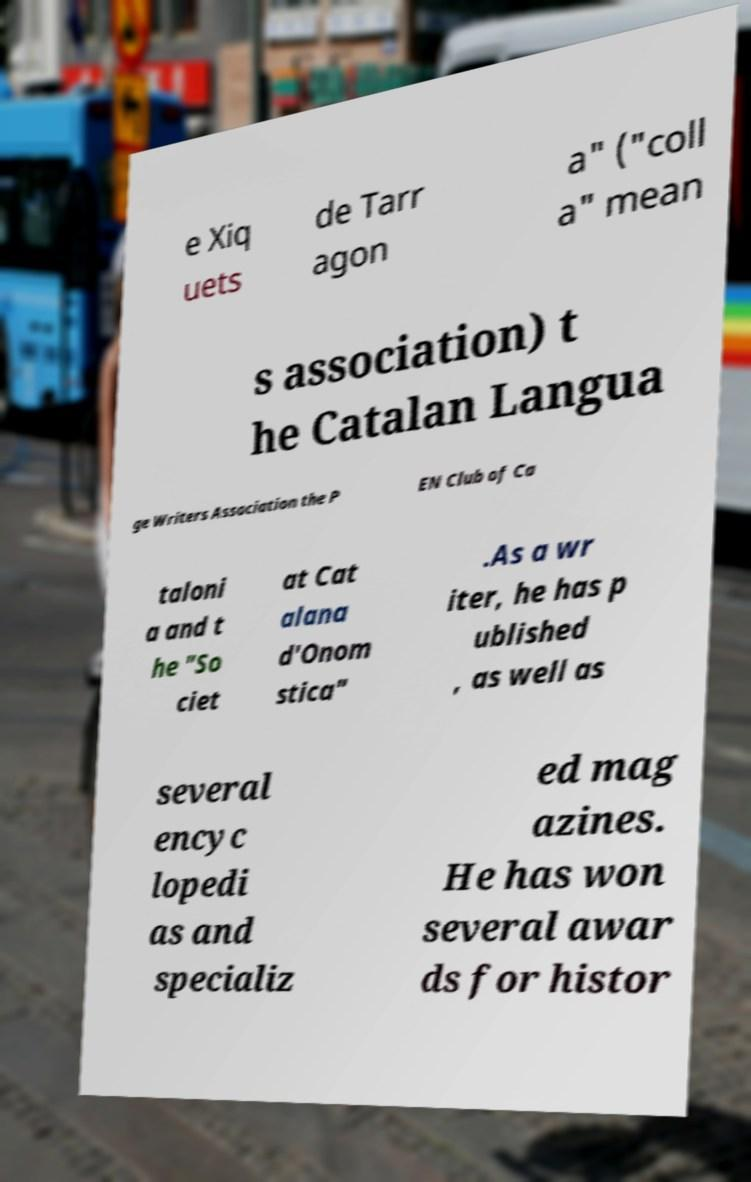Please read and relay the text visible in this image. What does it say? e Xiq uets de Tarr agon a" ("coll a" mean s association) t he Catalan Langua ge Writers Association the P EN Club of Ca taloni a and t he "So ciet at Cat alana d'Onom stica" .As a wr iter, he has p ublished , as well as several encyc lopedi as and specializ ed mag azines. He has won several awar ds for histor 